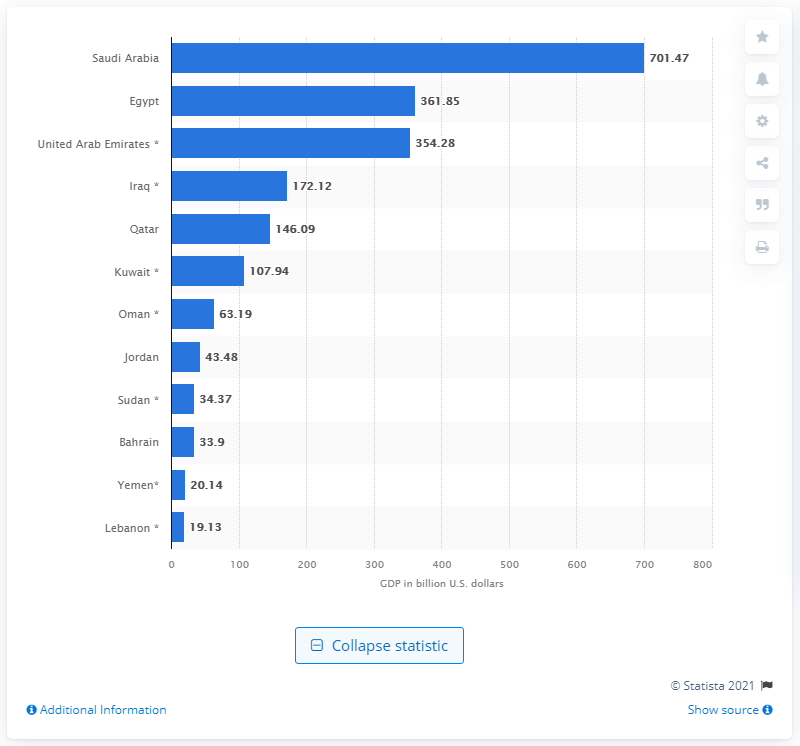Highlight a few significant elements in this photo. In 2020, the Gross Domestic Product (GDP) of Saudi Arabia was 701.47 billion dollars. 